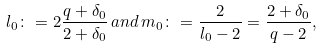Convert formula to latex. <formula><loc_0><loc_0><loc_500><loc_500>l _ { 0 } \colon = 2 \frac { q + \delta _ { 0 } } { 2 + \delta _ { 0 } } \, a n d \, m _ { 0 } \colon = \frac { 2 } { l _ { 0 } - 2 } = \frac { 2 + \delta _ { 0 } } { q - 2 } ,</formula> 